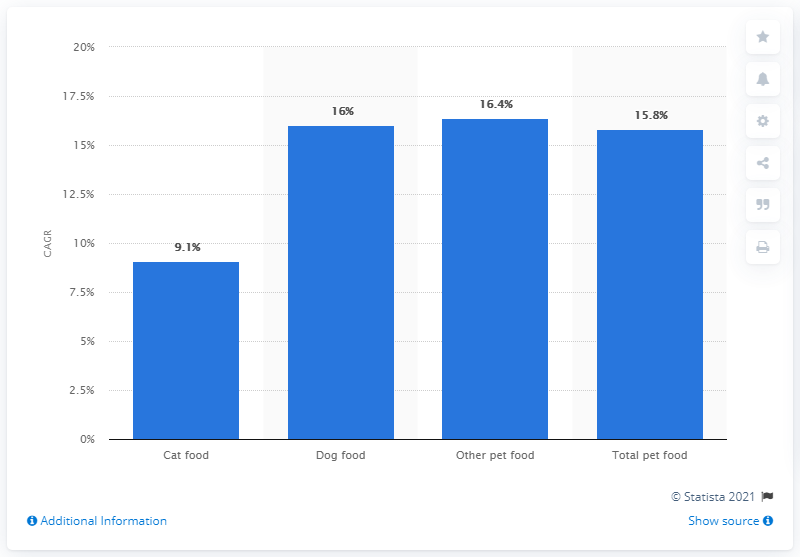Point out several critical features in this image. I'm sorry, but I'm not sure what you are trying to say. Could you please provide more context or clarify your question? Dog food sales in India are expected to increase at a compound annual growth rate (CAGR) of 16% between 2019 and 2023. What is the percentage of dog food? 16%. 